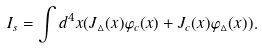<formula> <loc_0><loc_0><loc_500><loc_500>I _ { s } = \int d ^ { 4 } x ( J _ { \vartriangle } ( x ) \varphi _ { c } ( x ) + J _ { c } ( x ) \varphi _ { \vartriangle } ( x ) ) .</formula> 